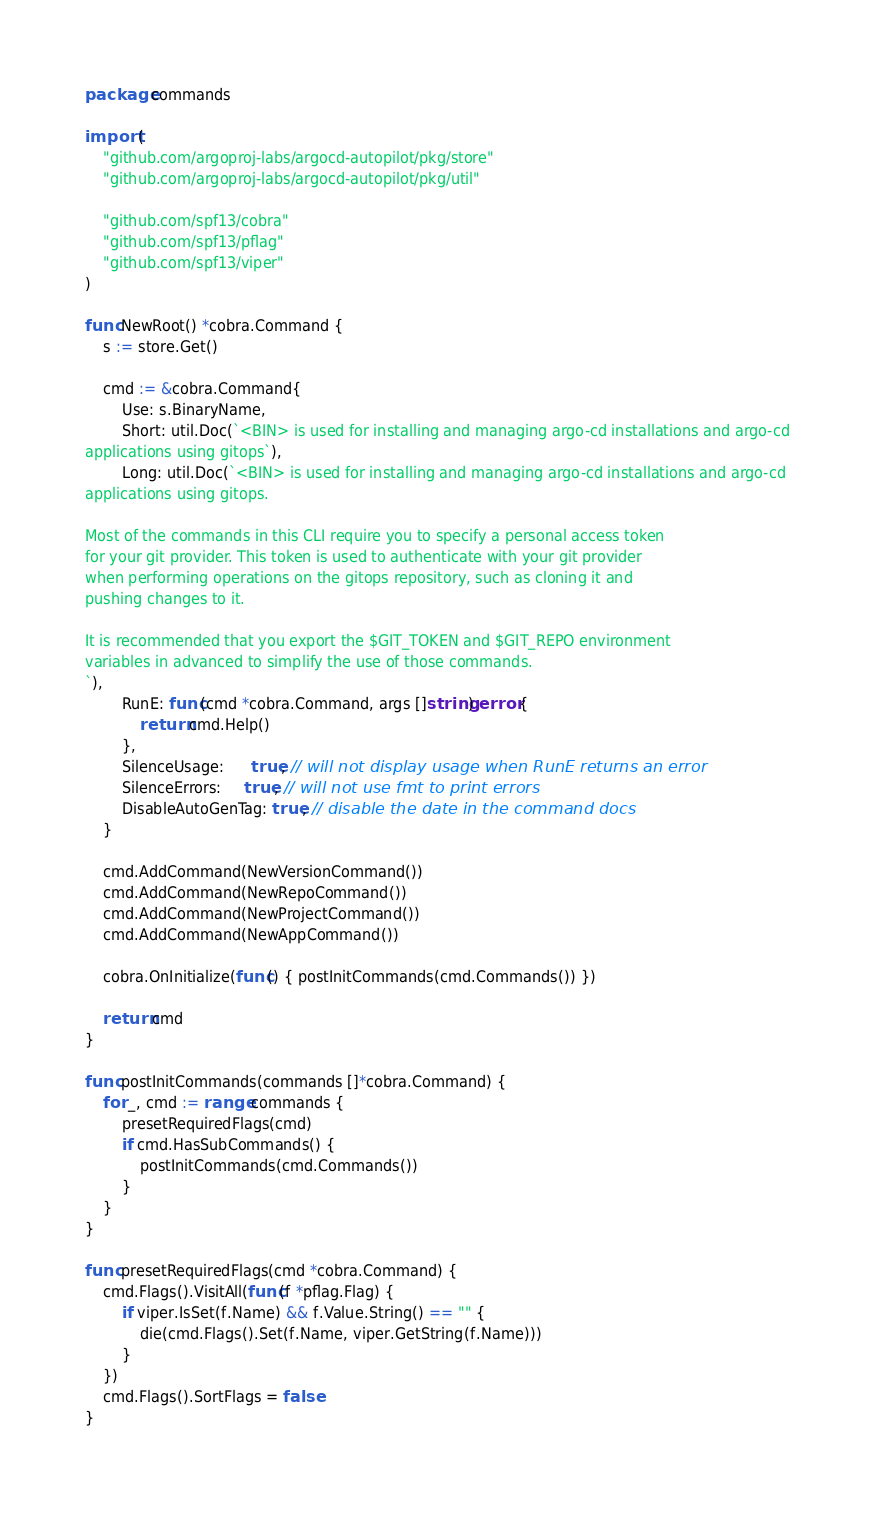Convert code to text. <code><loc_0><loc_0><loc_500><loc_500><_Go_>package commands

import (
	"github.com/argoproj-labs/argocd-autopilot/pkg/store"
	"github.com/argoproj-labs/argocd-autopilot/pkg/util"

	"github.com/spf13/cobra"
	"github.com/spf13/pflag"
	"github.com/spf13/viper"
)

func NewRoot() *cobra.Command {
	s := store.Get()

	cmd := &cobra.Command{
		Use: s.BinaryName,
		Short: util.Doc(`<BIN> is used for installing and managing argo-cd installations and argo-cd
applications using gitops`),
		Long: util.Doc(`<BIN> is used for installing and managing argo-cd installations and argo-cd
applications using gitops.
		
Most of the commands in this CLI require you to specify a personal access token
for your git provider. This token is used to authenticate with your git provider
when performing operations on the gitops repository, such as cloning it and
pushing changes to it.

It is recommended that you export the $GIT_TOKEN and $GIT_REPO environment
variables in advanced to simplify the use of those commands.
`),
		RunE: func(cmd *cobra.Command, args []string) error {
			return cmd.Help()
		},
		SilenceUsage:      true, // will not display usage when RunE returns an error
		SilenceErrors:     true, // will not use fmt to print errors
		DisableAutoGenTag: true, // disable the date in the command docs
	}

	cmd.AddCommand(NewVersionCommand())
	cmd.AddCommand(NewRepoCommand())
	cmd.AddCommand(NewProjectCommand())
	cmd.AddCommand(NewAppCommand())

	cobra.OnInitialize(func() { postInitCommands(cmd.Commands()) })

	return cmd
}

func postInitCommands(commands []*cobra.Command) {
	for _, cmd := range commands {
		presetRequiredFlags(cmd)
		if cmd.HasSubCommands() {
			postInitCommands(cmd.Commands())
		}
	}
}

func presetRequiredFlags(cmd *cobra.Command) {
	cmd.Flags().VisitAll(func(f *pflag.Flag) {
		if viper.IsSet(f.Name) && f.Value.String() == "" {
			die(cmd.Flags().Set(f.Name, viper.GetString(f.Name)))
		}
	})
	cmd.Flags().SortFlags = false
}
</code> 